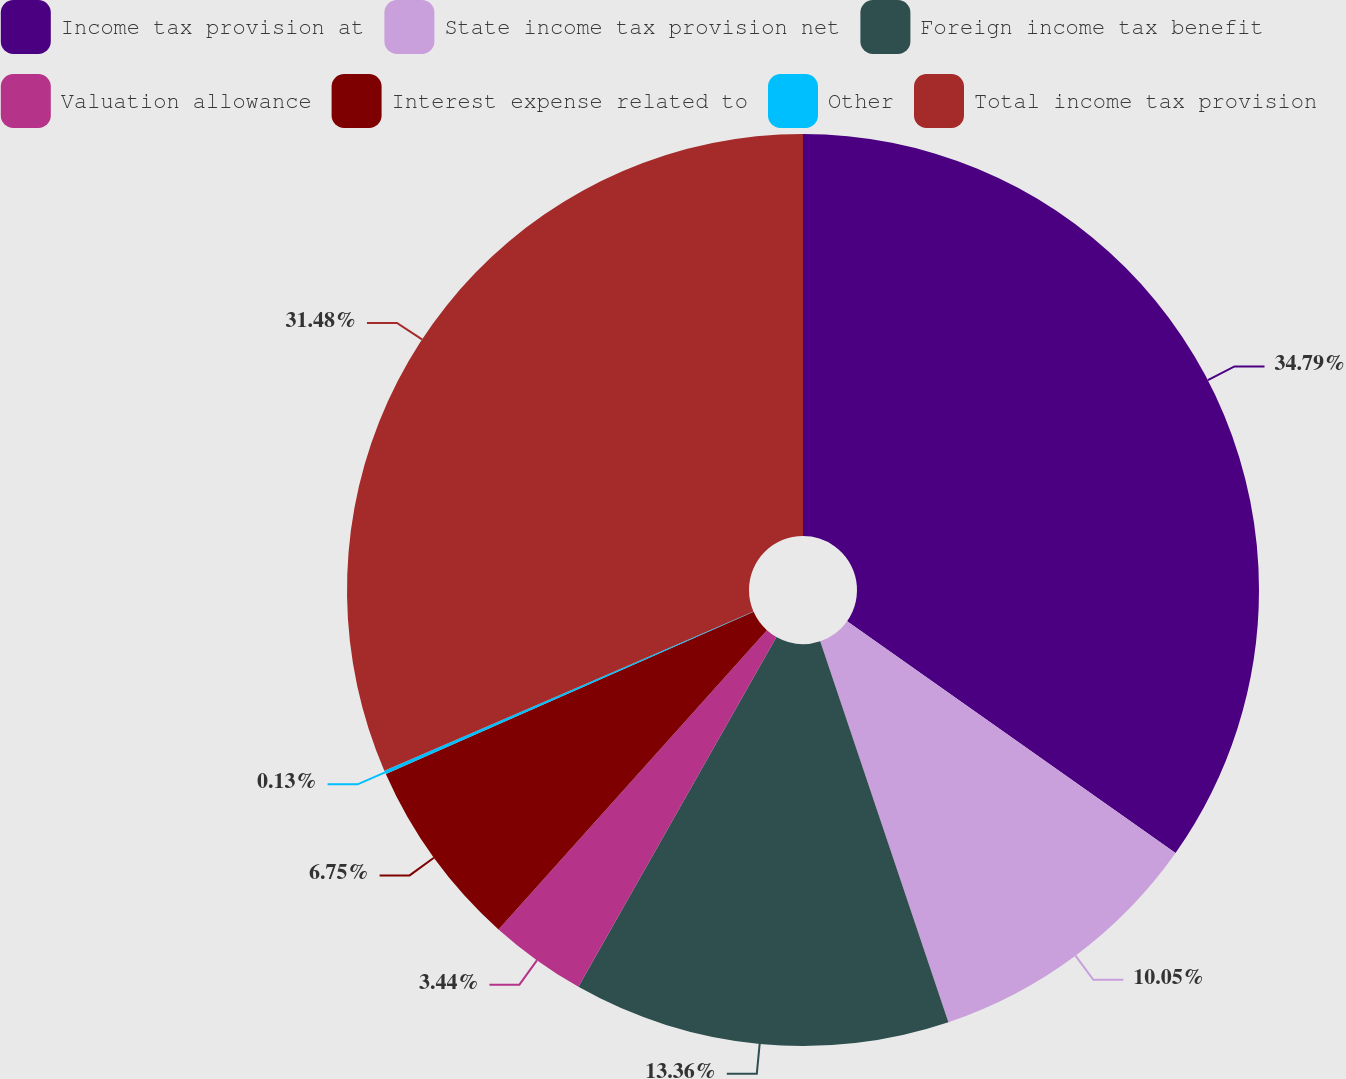Convert chart. <chart><loc_0><loc_0><loc_500><loc_500><pie_chart><fcel>Income tax provision at<fcel>State income tax provision net<fcel>Foreign income tax benefit<fcel>Valuation allowance<fcel>Interest expense related to<fcel>Other<fcel>Total income tax provision<nl><fcel>34.78%<fcel>10.05%<fcel>13.36%<fcel>3.44%<fcel>6.75%<fcel>0.13%<fcel>31.48%<nl></chart> 